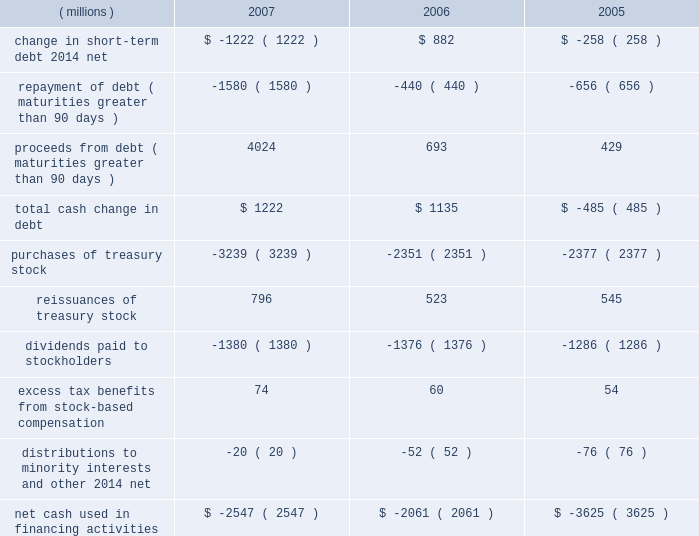Approximately $ 55 million , which is reported as 201cinvestments 201d in the consolidated balance sheet and as 201cpurchases of marketable securities and investments 201d in the consolidated statement of cash flows .
The recovery of approximately $ 25 million of this investment in 2007 reduced 201cinvestments 201d and is shown in cash flows within 201cproceeds from sale of marketable securities and investments . 201d this investment is discussed in more detail under the preceding section entitled industrial and transportation business .
Additional purchases of investments include additional survivor benefit insurance and equity investments .
Cash flows from financing activities : years ended december 31 .
Total debt at december 31 , 2007 , was $ 4.920 billion , up from $ 3.553 billion at year-end 2006 .
The net change in short-term debt is primarily due to commercial paper activity .
In 2007 , the repayment of debt for maturities greater than 90 days is primarily comprised of commercial paper repayments of approximately $ 1.15 billion and the november 2007 redemption of approximately $ 322 million in convertible notes .
In 2007 , proceeds from debt included long-term debt and commercial paper issuances totaling approximately $ 4 billion .
This was comprised of eurobond issuances in december 2007 and july 2007 totaling approximately $ 1.5 billion in u.s .
Dollars , a march 2007 long-term debt issuance of $ 750 million and a december 2007 fixed rate note issuance of $ 500 million , plus commercial paper issuances ( maturities greater than 90 days ) of approximately $ 1.25 billion .
Increases in long-term debt have been used , in part , to fund share repurchase activities .
The company accelerated purchases of treasury stock when compared to prior years , buying back $ 3.2 billion in shares in 2007 .
Total debt was 30% ( 30 % ) of total capital ( total capital is defined as debt plus equity ) , compared with 26% ( 26 % ) at year-end 2006 .
Debt securities , including 2007 debt issuances , the company 2019s shelf registration , dealer remarketable securities and convertible notes , are all discussed in more detail in note 10 .
The company has a "well-known seasoned issuer" shelf registration statement , effective february 24 , 2006 , to register an indeterminate amount of debt or equity securities for future sales .
On june 15 , 2007 , the company registered 150718 shares of the company's common stock under this shelf on behalf of and for the sole benefit of the selling stockholders in connection with the company's acquisition of assets of diamond productions , inc .
The company intends to use the proceeds from future securities sales off this shelf for general corporate purposes .
In connection with this shelf registration , in june 2007 the company established a medium-term notes program through which up to $ 3 billion of medium-term notes may be offered .
In december 2007 , 3m issued a five-year , $ 500 million , fixed rate note with a coupon rate of 4.65% ( 4.65 % ) under this medium-term notes program .
This program has a remaining capacity of $ 2.5 billion as of december 31 , 2007 .
The company 2019s $ 350 million of dealer remarketable securities ( classified as current portion of long-term debt ) were remarketed for one year in december 2007 .
At december 31 , 2007 , $ 350 million of dealer remarketable securities ( final maturity 2010 ) and $ 62 million of floating rate notes ( final maturity 2044 ) are classified as current portion of long- term debt as the result of put provisions associated with these debt instruments .
The company has convertible notes with a book value of $ 222 million at december 31 , 2007 .
The next put option date for these convertible notes is november 2012 .
In november 2007 , 364598 outstanding bonds were redeemed resulting in a payout from 3m of approximately $ 322 million .
Repurchases of common stock are made to support the company 2019s stock-based employee compensation plans and for other corporate purposes .
In february 2007 , 3m 2019s board of directors authorized a two-year share repurchase of up to $ 7.0 billion for the period from february 12 , 2007 to february 28 , 2009 .
As of december 31 , 2007 , approximately $ 4.1 billion remained available for repurchase .
Refer to the table titled 201cissuer purchases of equity securities 201d in part ii , item 5 , for more information. .
What was the percent of the total change in debt at december 31 , 2007 from 2006? 
Computations: ((4.920 - 3.553) / 3.553)
Answer: 0.38475. 